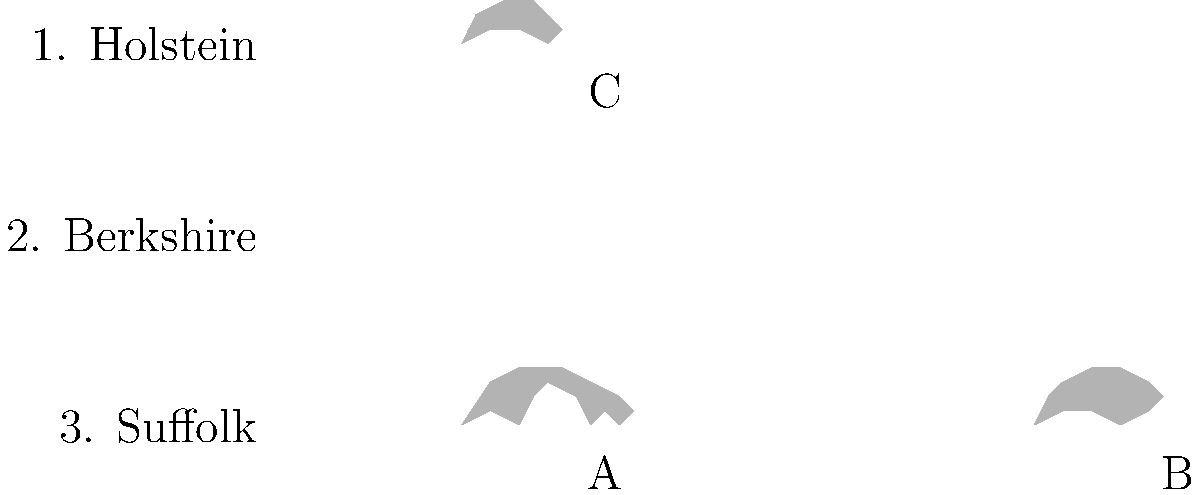Match the livestock breeds to their corresponding silhouettes in the diagram. Which letter (A, B, or C) represents the Suffolk breed? To answer this question, let's analyze each silhouette and match it to the corresponding breed:

1. Silhouette A: This silhouette shows a larger animal with a distinctive rectangular body shape and a prominent udder. These characteristics are typical of dairy cattle breeds, such as the Holstein.

2. Silhouette B: This silhouette depicts a shorter, rounder animal with a snout-like protrusion. These features are characteristic of pig breeds, including the Berkshire.

3. Silhouette C: This silhouette shows a medium-sized animal with a woolly appearance and a distinct sheep-like shape. These traits are typical of sheep breeds, such as the Suffolk.

Given the options provided in the diagram:
1. Holstein (dairy cattle)
2. Berkshire (pig)
3. Suffolk (sheep)

We can conclude that:
- Silhouette A matches the Holstein
- Silhouette B matches the Berkshire
- Silhouette C matches the Suffolk

Therefore, the Suffolk breed is represented by letter C in the diagram.
Answer: C 